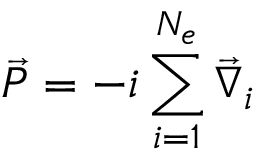<formula> <loc_0><loc_0><loc_500><loc_500>\vec { P } = - i \sum _ { i = 1 } ^ { N _ { e } } \vec { \nabla } _ { i }</formula> 